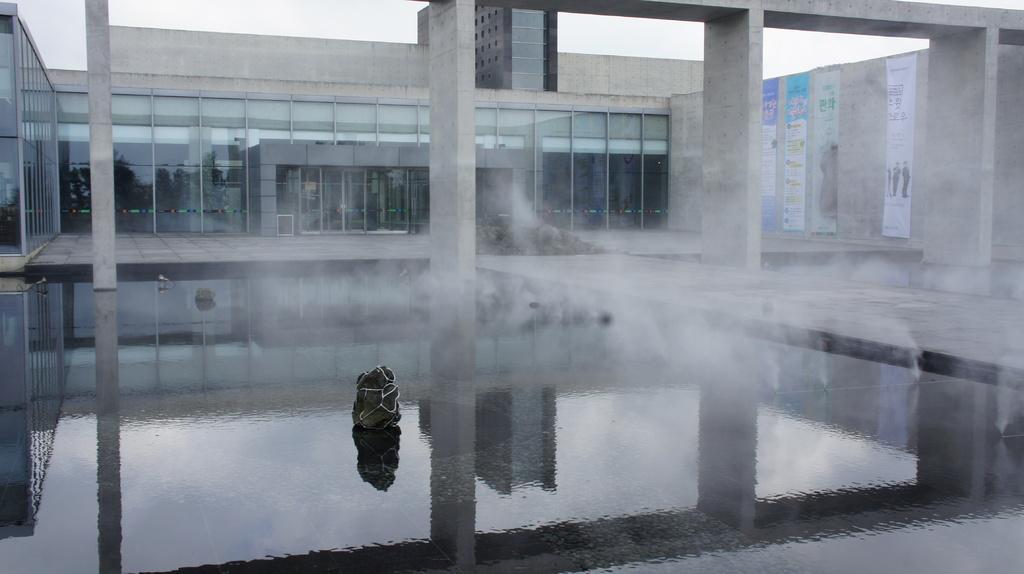Describe this image in one or two sentences. In this image in the center there is water. In the background there is building and on the right side there are banners on the wall with some text written on it, and the sky is cloudy and there is smoke coming from the water which is in the center. 